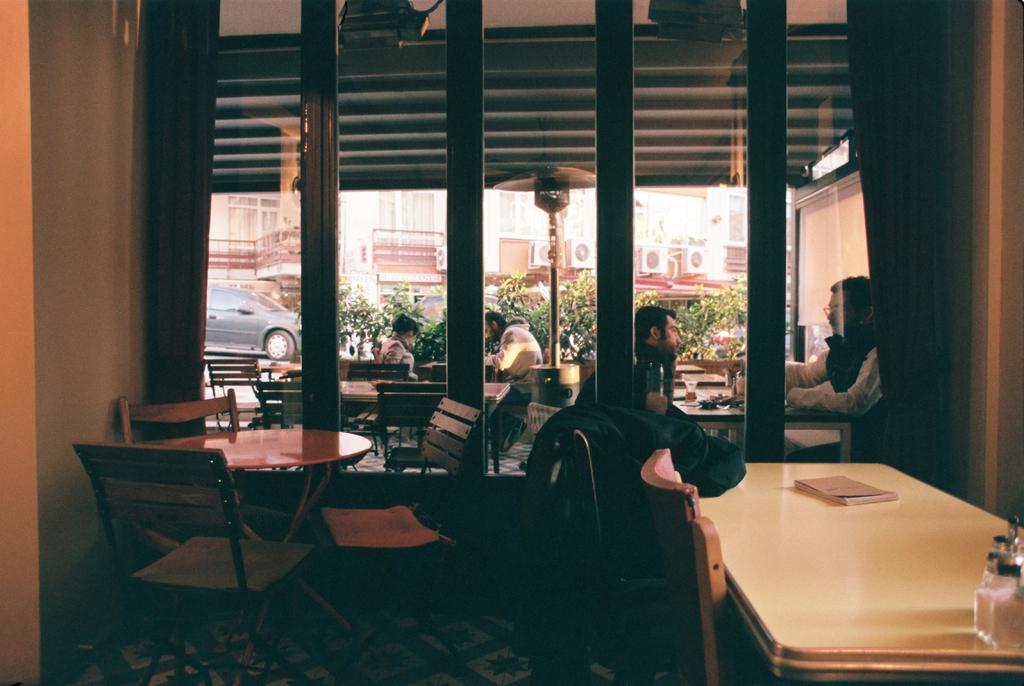In one or two sentences, can you explain what this image depicts? In this picture here is a wall here is table, and chairs here is a book on table. in front a person is sitting on a chair, and in front of him a man is sitting ,he is wearing a shirt. and in front there are trees and car is moving on the road. here is the building, and here is the ac fan. 